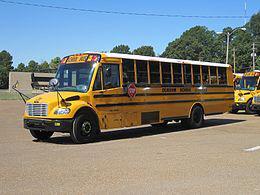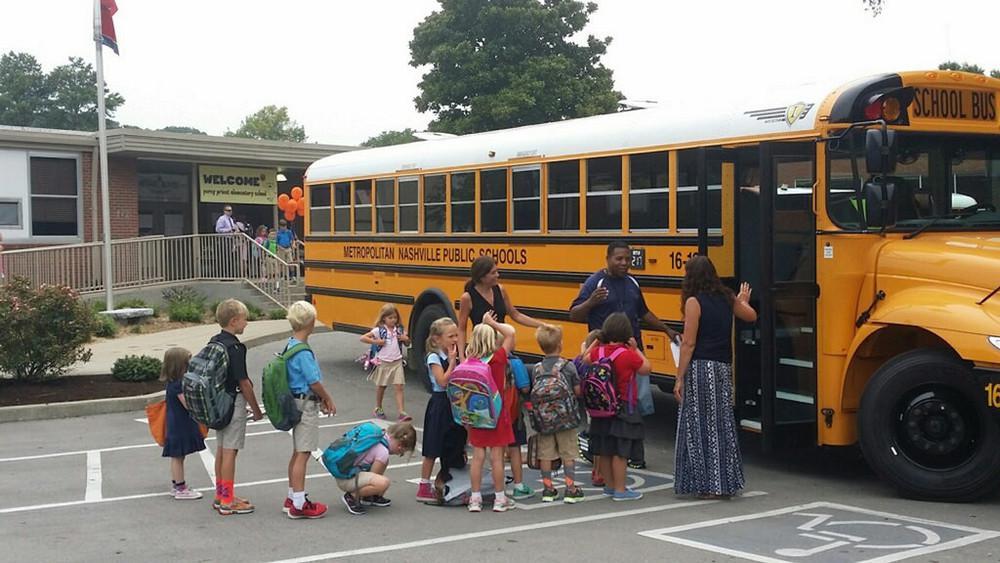The first image is the image on the left, the second image is the image on the right. For the images displayed, is the sentence "An image shows a man standing to the left, and at least one child in front of the door of a flat-fronted school bus." factually correct? Answer yes or no. No. 